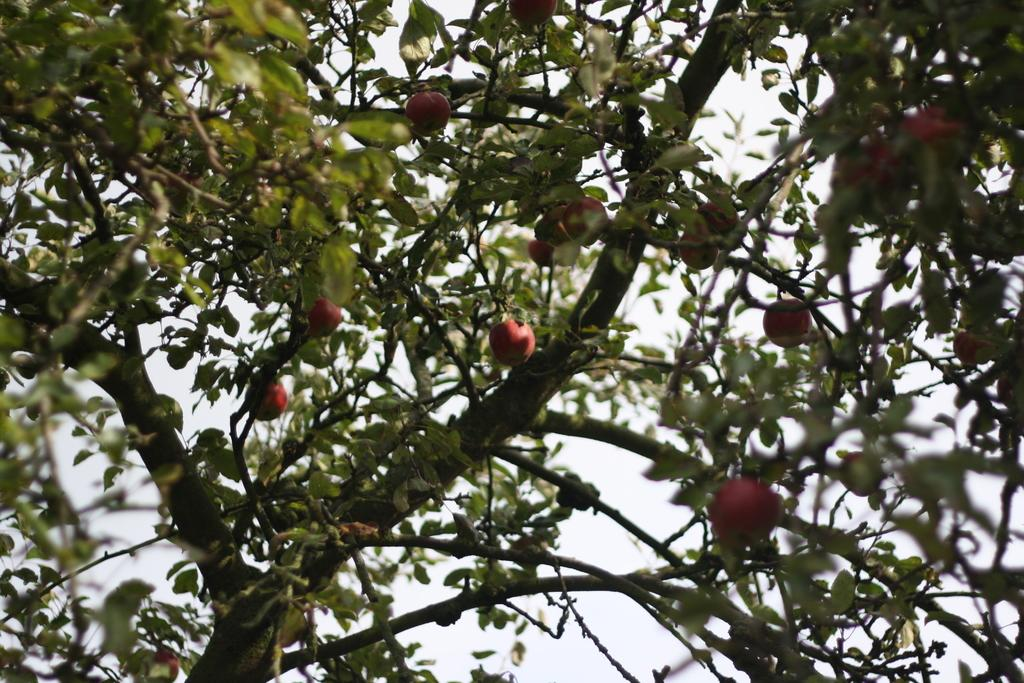What is the main object in the image? There is a tree in the image. What can be seen in the background of the image? The sky is visible in the background of the image. What is present on the tree? There are fruits and leaves on the tree. What is the range of the tree's branches in the image? The range of the tree's branches cannot be determined from the image alone, as it only provides a two-dimensional representation. 